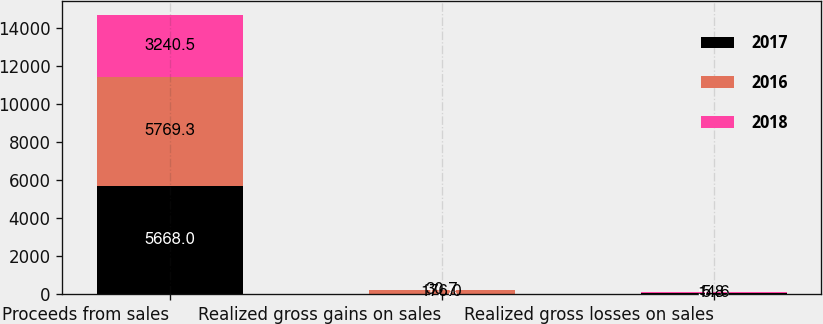Convert chart to OTSL. <chart><loc_0><loc_0><loc_500><loc_500><stacked_bar_chart><ecel><fcel>Proceeds from sales<fcel>Realized gross gains on sales<fcel>Realized gross losses on sales<nl><fcel>2017<fcel>5668<fcel>11.8<fcel>51.3<nl><fcel>2016<fcel>5769.3<fcel>176<fcel>5.8<nl><fcel>2018<fcel>3240.5<fcel>30.7<fcel>14.6<nl></chart> 